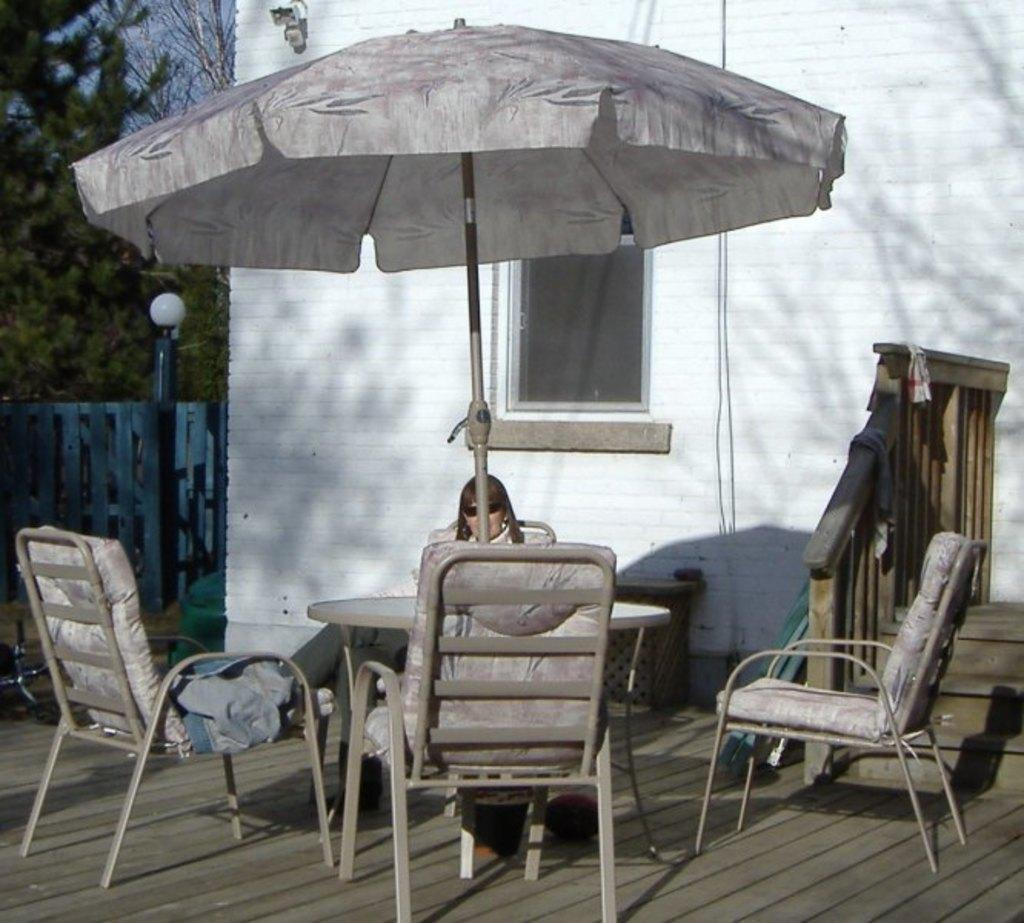What is the main subject in the center of the image? There are multiple subjects in the center of the image, including a building, a wall, a window, a pole, a fence, a staircase, a tent, a table, and chairs. Can you describe the person in the image? There is one person sitting in the center of the image. What can be seen in the background of the image? The sky and trees are visible in the background of the image. How many rabbits are hopping across the bridge in the image? There are no rabbits or bridges present in the image. 